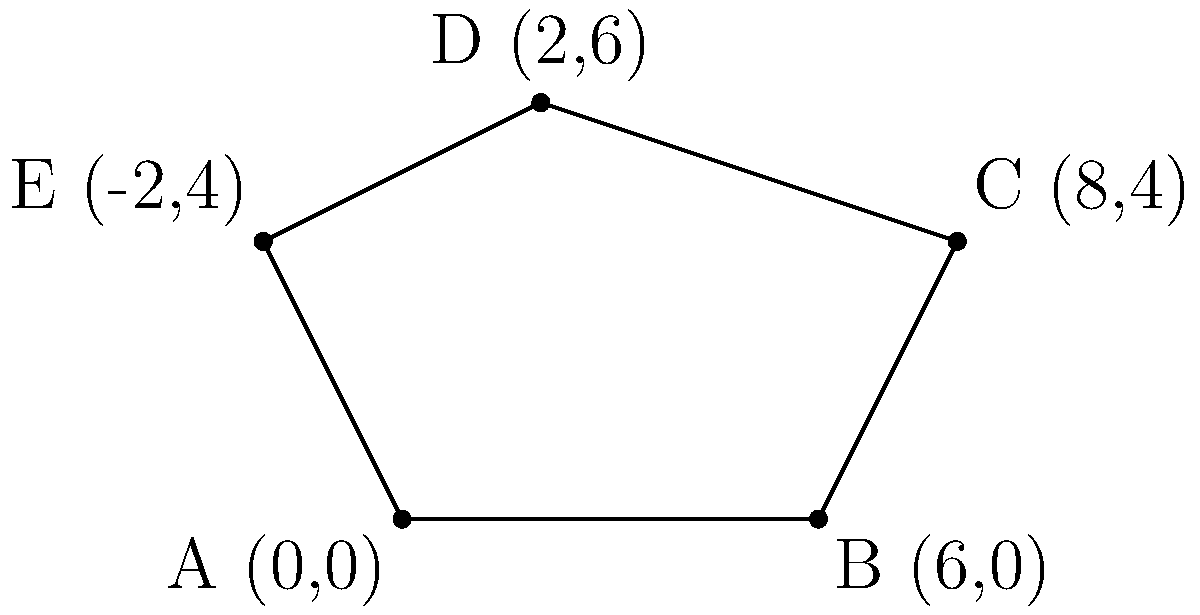As a forensic anthropologist consultant, you're tasked with determining the area of an irregularly shaped ancient settlement. The settlement's boundary is represented by the coordinates A(0,0), B(6,0), C(8,4), D(2,6), and E(-2,4) in a Cartesian plane. Using the shoelace formula for the area of a polygon, calculate the total area of this ancient settlement in square units. To solve this problem, we'll use the shoelace formula, which is particularly useful for calculating the area of irregular polygons. The steps are as follows:

1) The shoelace formula for a polygon with vertices $(x_1, y_1), (x_2, y_2), ..., (x_n, y_n)$ is:

   Area = $\frac{1}{2}|((x_1y_2 + x_2y_3 + ... + x_ny_1) - (y_1x_2 + y_2x_3 + ... + y_nx_1))|$

2) Let's organize our vertices:
   A(0,0), B(6,0), C(8,4), D(2,6), E(-2,4)

3) Now, let's apply the formula:

   $\frac{1}{2}|((0 \cdot 0 + 6 \cdot 4 + 8 \cdot 6 + 2 \cdot 4 + (-2) \cdot 0) - (0 \cdot 6 + 0 \cdot 8 + 4 \cdot 2 + 6 \cdot (-2) + 4 \cdot 0))|$

4) Simplify:
   $\frac{1}{2}|((0 + 24 + 48 + 8 + 0) - (0 + 0 + 8 - 12 + 0))|$

5) Calculate:
   $\frac{1}{2}|(80 - (-4))|$
   $\frac{1}{2}|84|$
   $42$

Therefore, the area of the ancient settlement is 42 square units.
Answer: 42 square units 